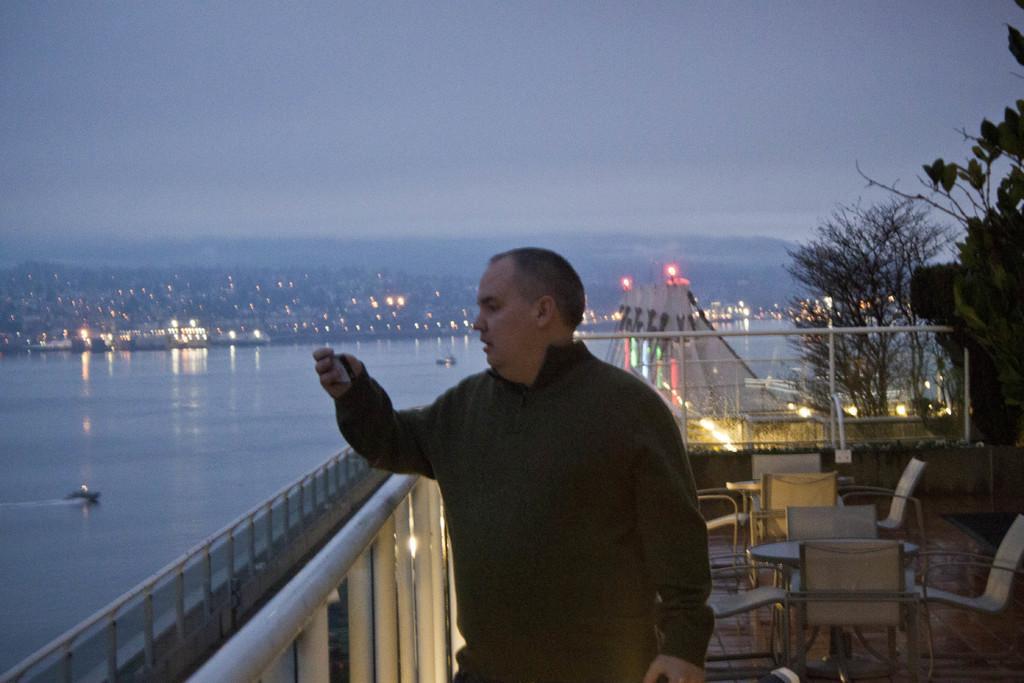In one or two sentences, can you explain what this image depicts? He is standing. we can see in the background there is a beautiful tree,lighting,sea and sky. 